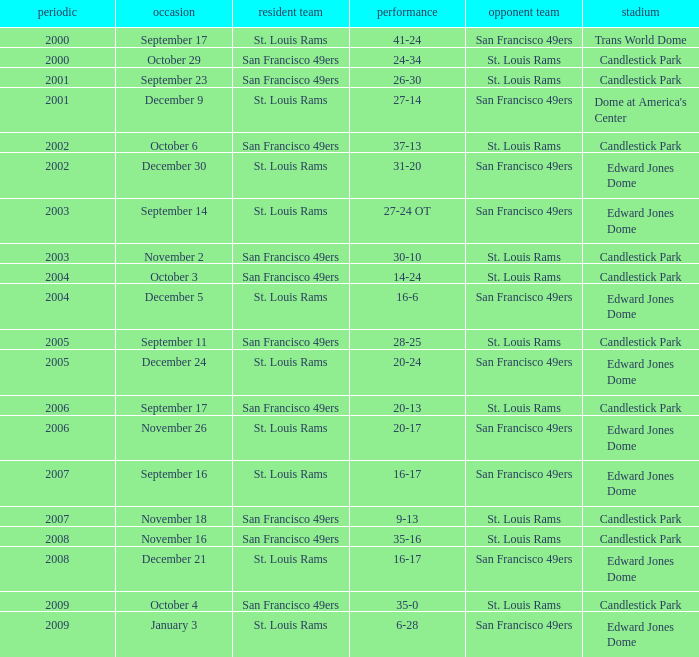What is the Result of the game on October 3? 14-24. 